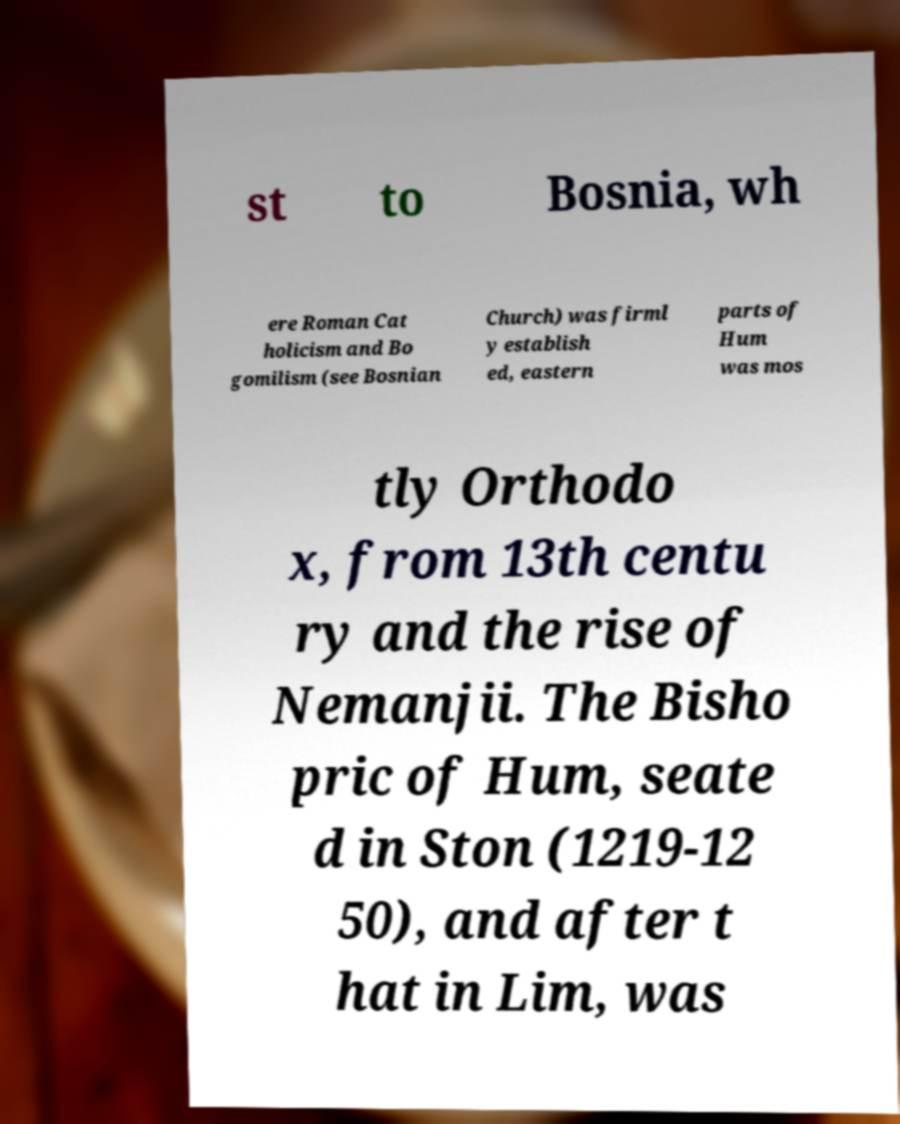For documentation purposes, I need the text within this image transcribed. Could you provide that? st to Bosnia, wh ere Roman Cat holicism and Bo gomilism (see Bosnian Church) was firml y establish ed, eastern parts of Hum was mos tly Orthodo x, from 13th centu ry and the rise of Nemanjii. The Bisho pric of Hum, seate d in Ston (1219-12 50), and after t hat in Lim, was 